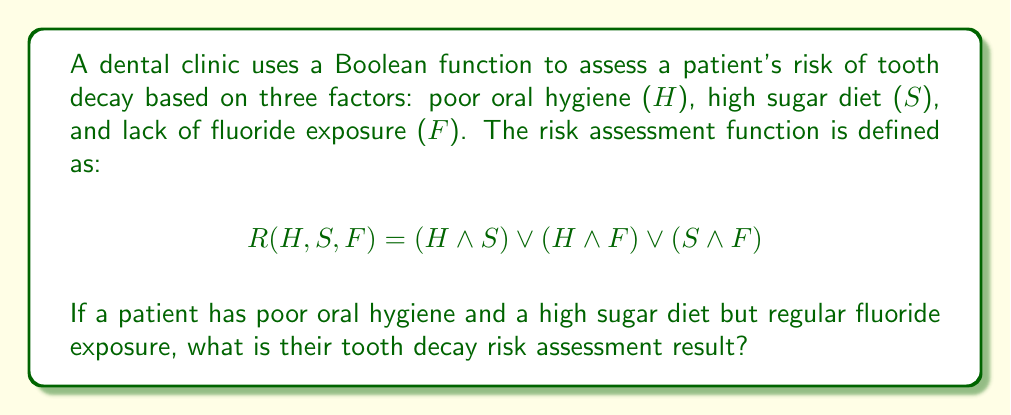Teach me how to tackle this problem. Let's approach this step-by-step:

1) We are given that the patient has:
   - Poor oral hygiene (H = 1)
   - High sugar diet (S = 1)
   - Regular fluoride exposure (F = 0)

2) Let's substitute these values into the risk assessment function:
   $R(H, S, F) = (H \land S) \lor (H \land F) \lor (S \land F)$
   $R(1, 1, 0) = (1 \land 1) \lor (1 \land 0) \lor (1 \land 0)$

3) Now, let's evaluate each part of the function:
   - $(1 \land 1) = 1$ (true AND true = true)
   - $(1 \land 0) = 0$ (true AND false = false)
   - $(1 \land 0) = 0$ (true AND false = false)

4) Substituting these results:
   $R(1, 1, 0) = 1 \lor 0 \lor 0$

5) Finally, we evaluate the OR operations:
   $1 \lor 0 \lor 0 = 1$ (true OR false OR false = true)

Therefore, the risk assessment function returns 1 (true), indicating a high risk of tooth decay for this patient.
Answer: 1 